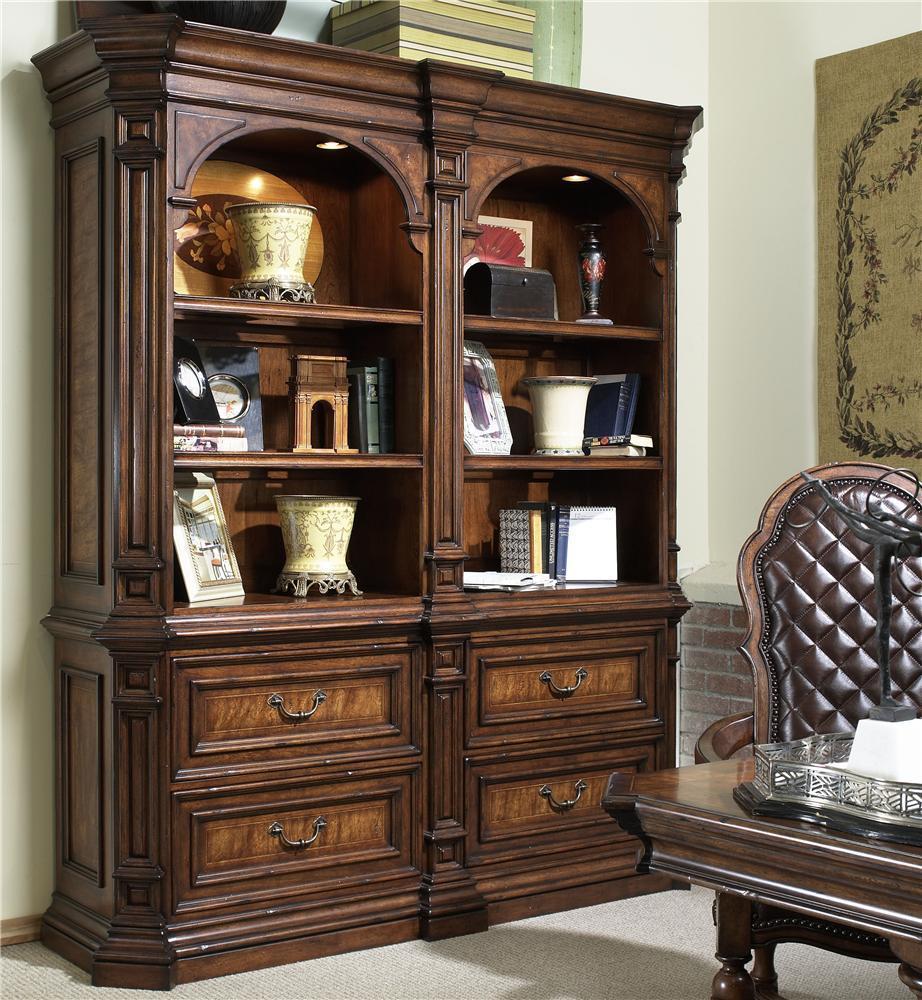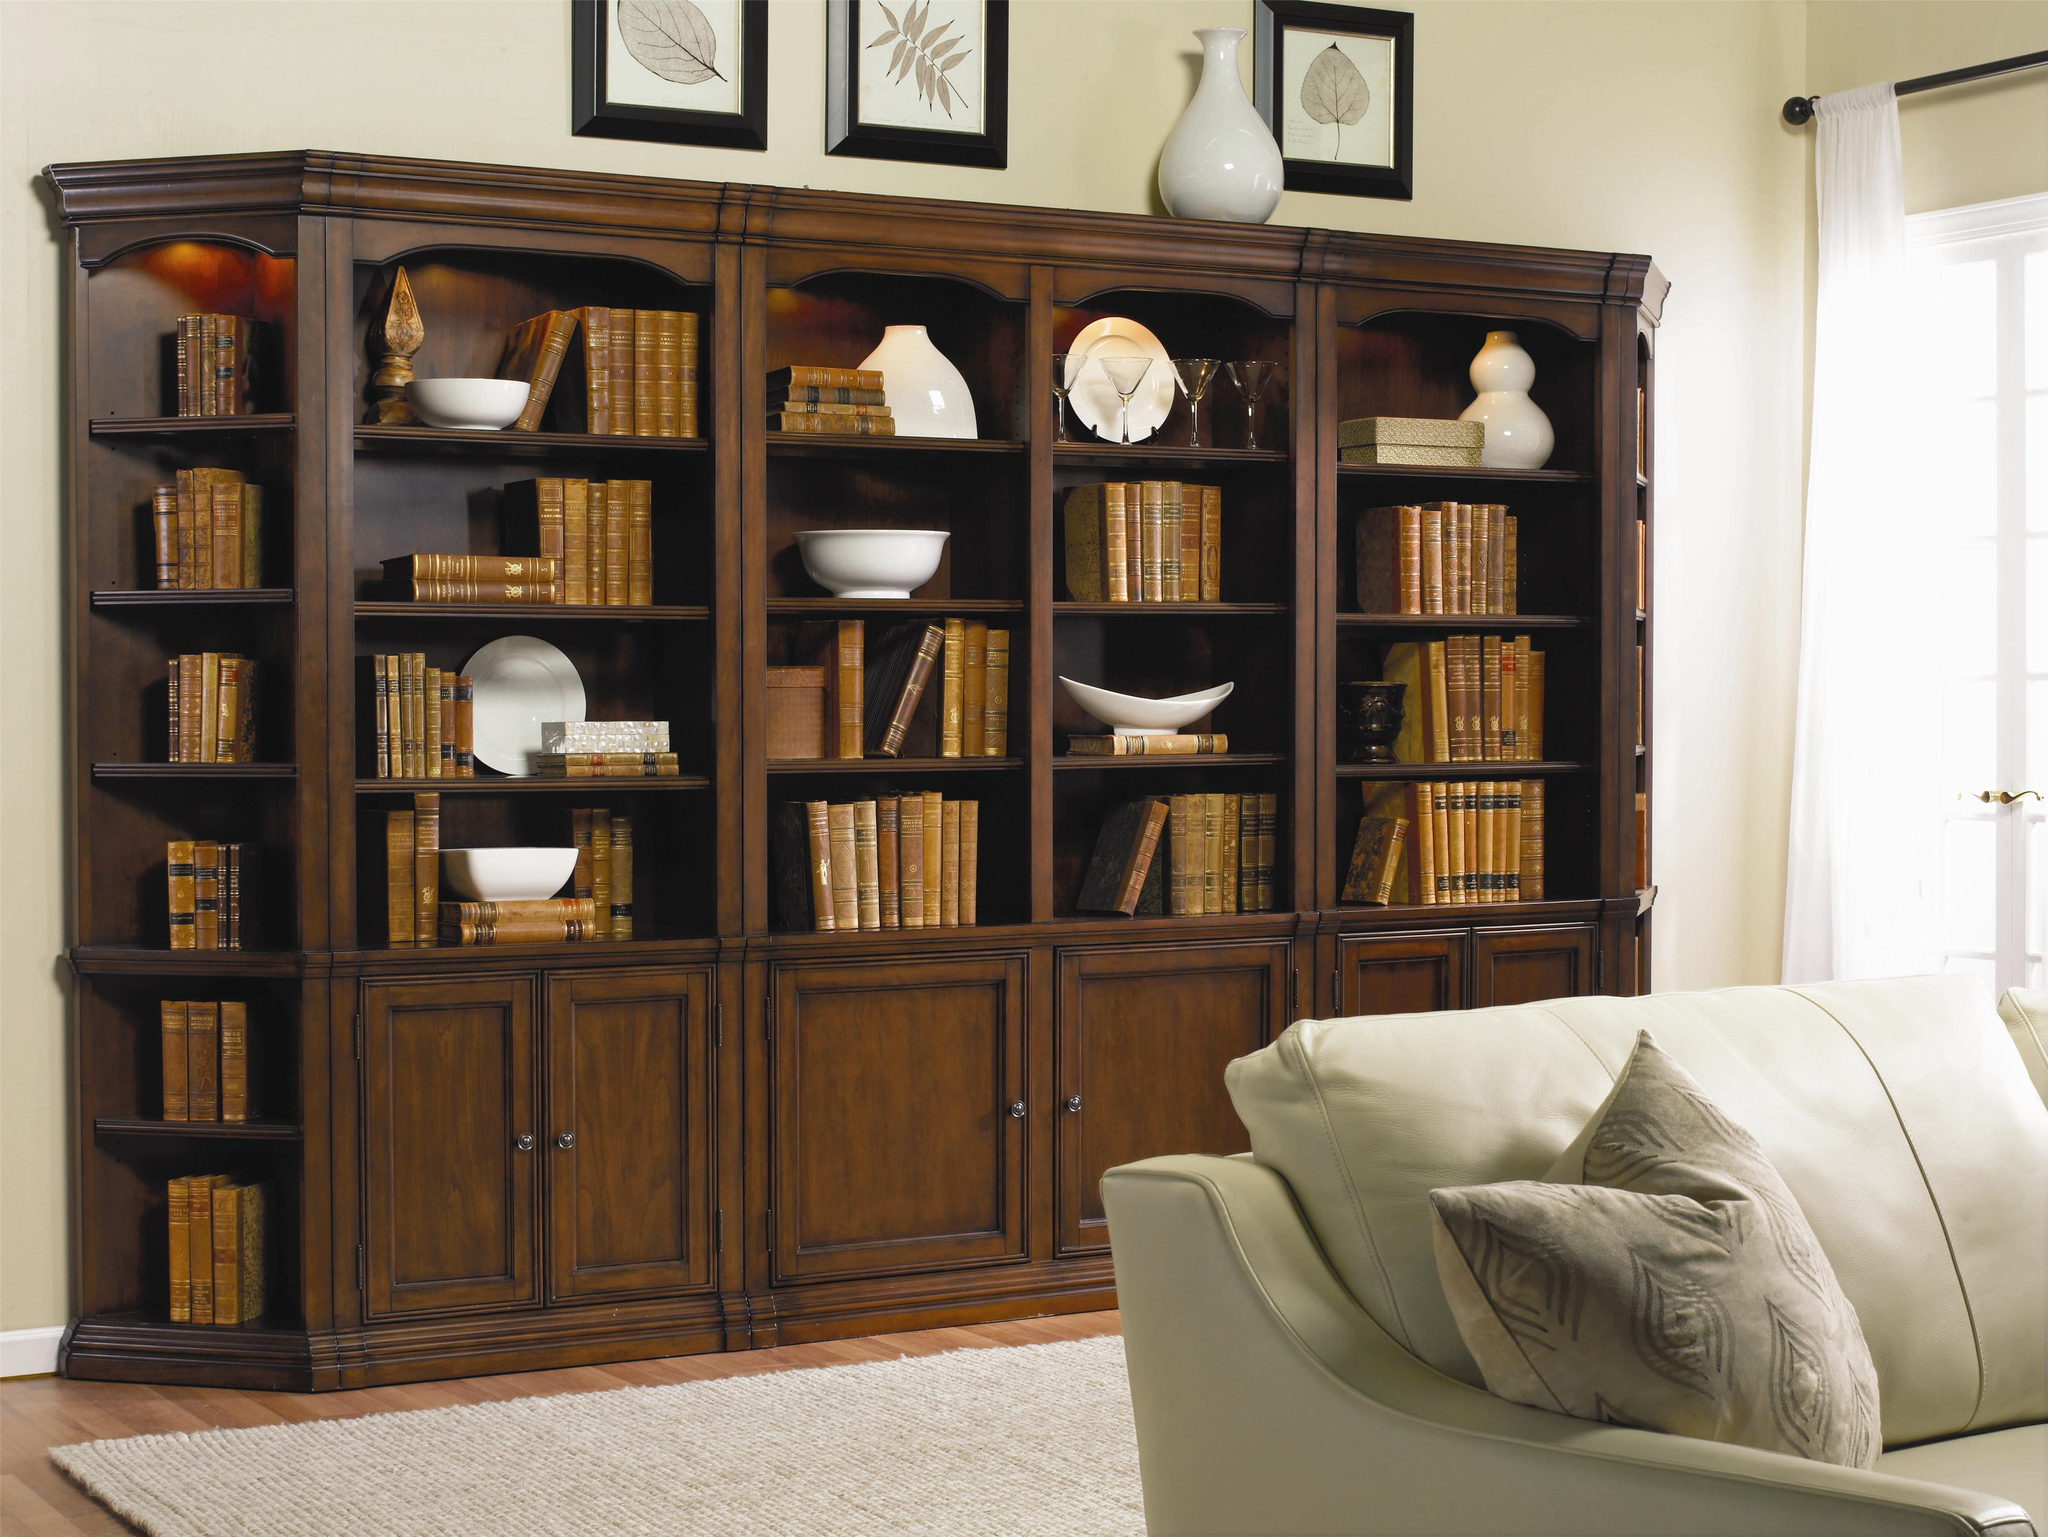The first image is the image on the left, the second image is the image on the right. Given the left and right images, does the statement "There is an empty case of bookshelf." hold true? Answer yes or no. No. 